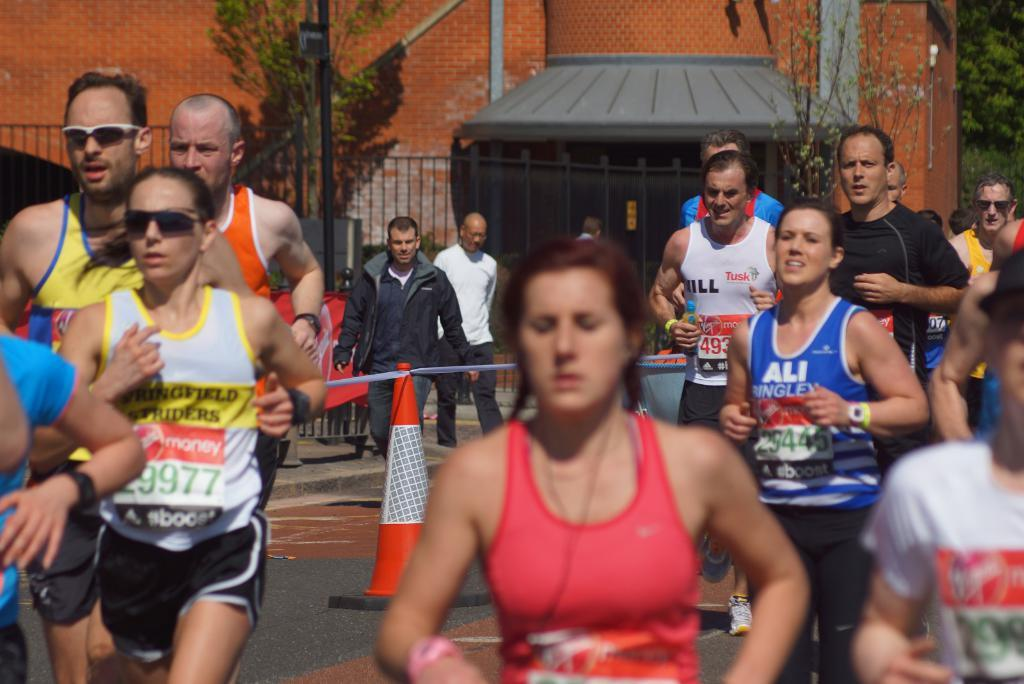<image>
Describe the image concisely. Runners competing in a marathon are seen in this photo, including #29445 wearing a blue tank top that says ALI. 